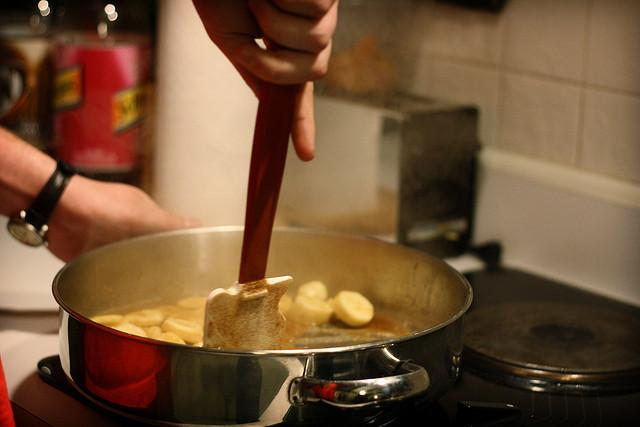What action is the person doing?

Choices:
A) stirring
B) eating
C) kneading
D) chopping stirring 